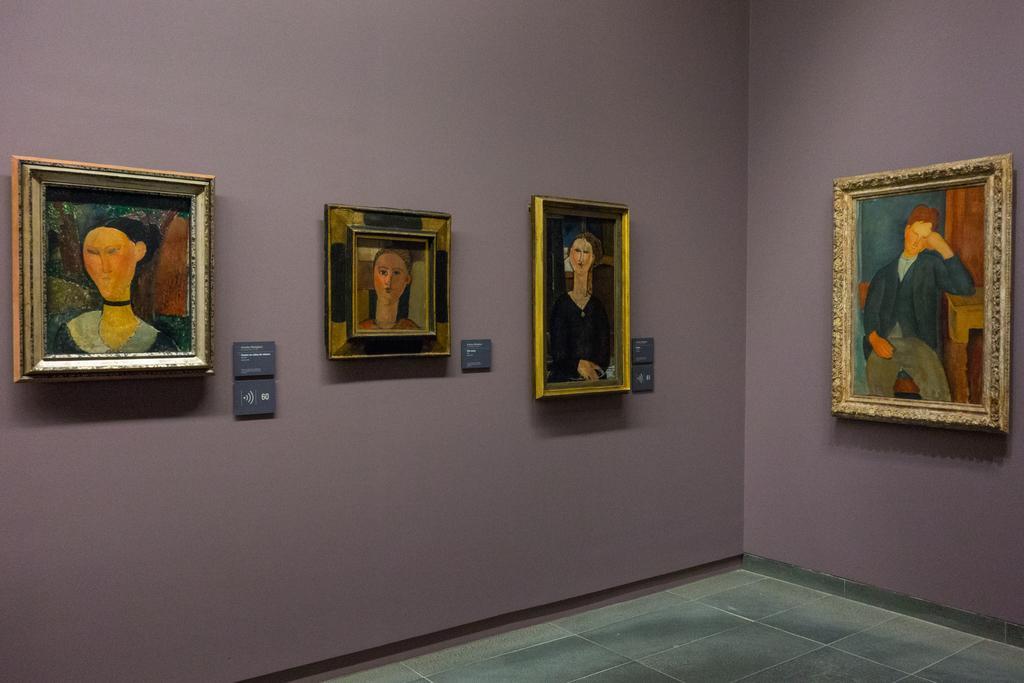Describe this image in one or two sentences. In this picture we can see a wall in the background, there are four photo frames on the wall, we can see paintings of persons in these frames, there are some boards on the wall, at the bottom there is floor. 